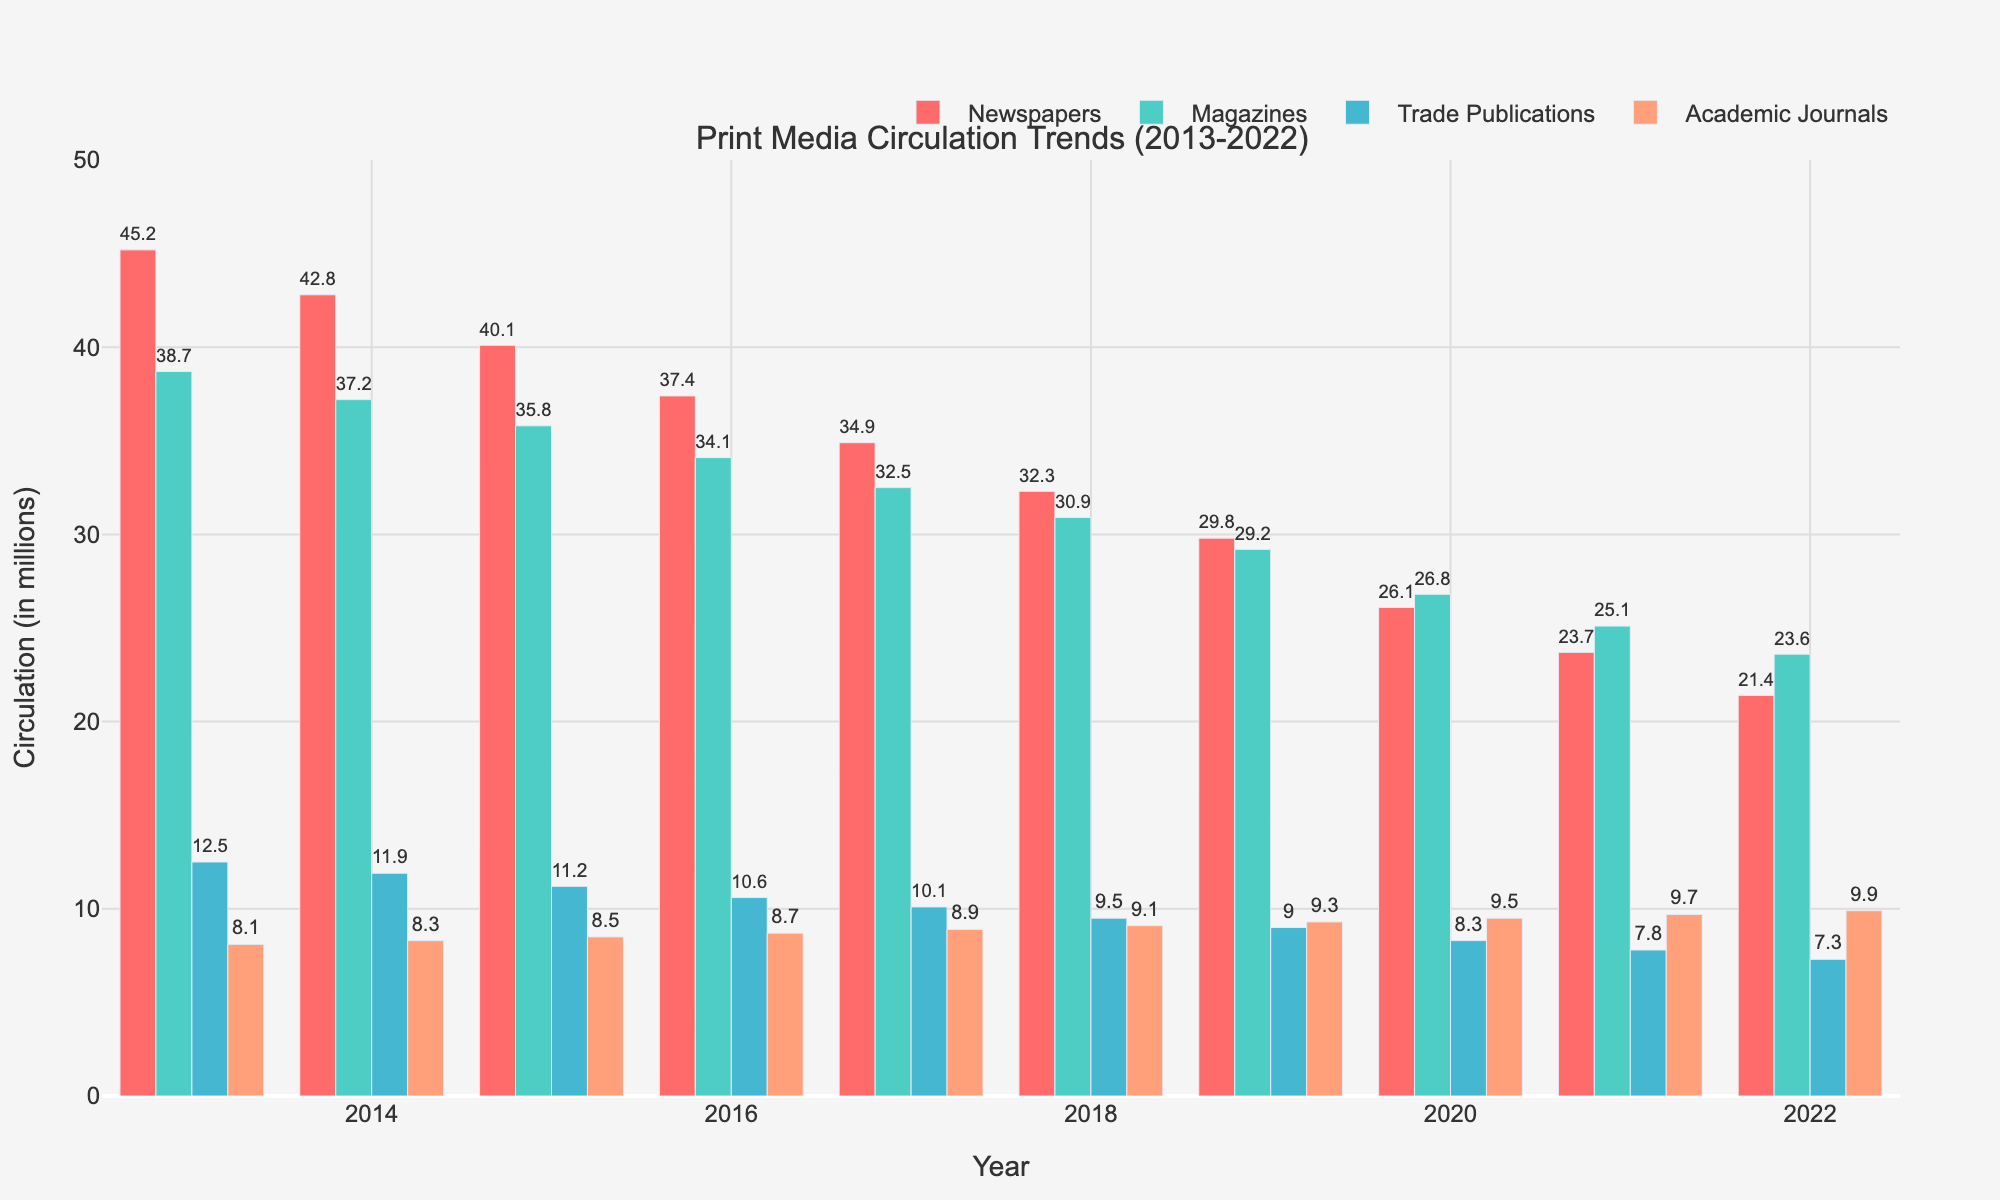How did the circulation of newspapers change from 2013 to 2022? To determine the change, look at the values for newspapers in 2013 and 2022. The value in 2013 is 45.2 million, and in 2022 it is 21.4 million. The difference is 45.2 - 21.4 = 23.8 million.
Answer: 23.8 million decrease Which publication type had the smallest decline in circulation over the period? Compare the decline for each publication type from 2013 to 2022. Newspapers: 45.2 - 21.4 = 23.8 million, Magazines: 38.7 - 23.6 = 15.1 million, Trade Publications: 12.5 - 7.3 = 5.2 million, Academic Journals: 8.1 - 9.9 = increase of 1.8 million. Trade Publications had the smallest decline.
Answer: Trade Publications In which year did magazines see the largest single-year drop in circulation? Evaluate the year-over-year decrease. The largest drop for magazines is from 2019 to 2020, with a decrease of 29.2 - 26.8 = 2.4 million.
Answer: 2020 What was the average circulation of academic journals over the decade? Sum the circulation values for academic journals from 2013 to 2022 and divide by the number of years. (8.1 + 8.3 + 8.5 + 8.7 + 8.9 + 9.1 + 9.3 + 9.5 + 9.7 + 9.9) / 10 = 8.9 million.
Answer: 8.9 million How did the circulation of trade publications compare to magazines in 2020? Compare the values directly from the figure. In 2020, trade publications have a circulation of 8.3 million and magazines 26.8 million. Magazines have higher circulation.
Answer: Magazines had higher circulation What is the overall trend in newspaper circulation from 2013 to 2022? Newspapers show a continuously decreasing trend from 45.2 million in 2013 to 21.4 million in 2022.
Answer: Decreasing trend Which publication type saw an increase in circulation, and by how much from 2013 to 2022? By looking at the values from 2013 and 2022, Academic Journals increased from 8.1 million (2013) to 9.9 million (2022). The increase is 9.9 - 8.1 = 1.8 million.
Answer: Academic Journals, increased by 1.8 million Compare the 2015 circulation figures for magazines and academic journals. In 2015, the circulation for magazines is 35.8 million, and for academic journals, it is 8.5 million; thus, magazines have a substantially higher circulation.
Answer: Magazines had higher circulation What is the combined circulation of all publication types in 2017? Sum the circulation figures for all publication types in 2017. Newspapers: 34.9 million, Magazines: 32.5 million, Trade Publications: 10.1 million, Academic Journals: 8.9 million. 34.9 + 32.5 + 10.1 + 8.9 = 86.4 million.
Answer: 86.4 million Which publication type consistently had the highest circulation each year? By visual inspection, newspapers consistently have the highest circulation figures each year from 2013 to 2022.
Answer: Newspapers 